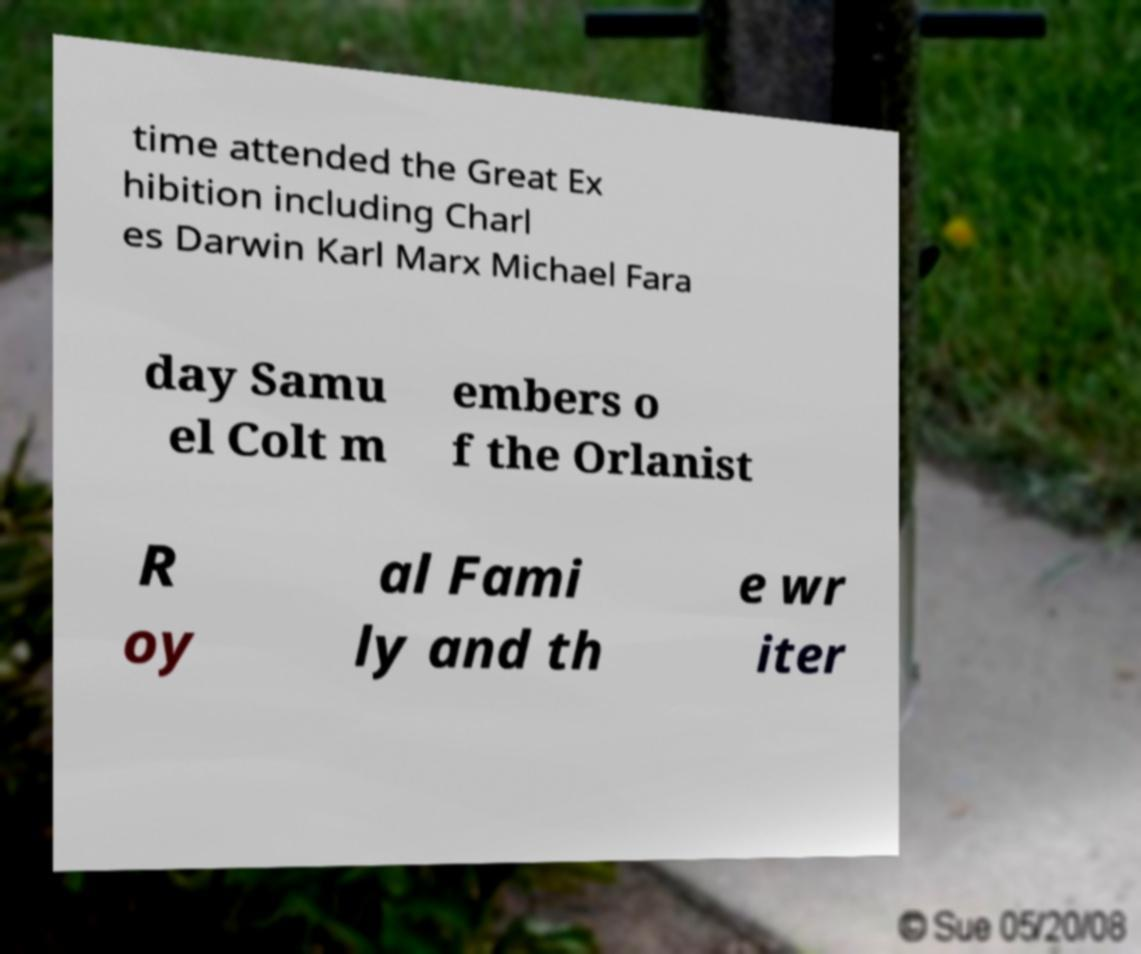Can you accurately transcribe the text from the provided image for me? time attended the Great Ex hibition including Charl es Darwin Karl Marx Michael Fara day Samu el Colt m embers o f the Orlanist R oy al Fami ly and th e wr iter 